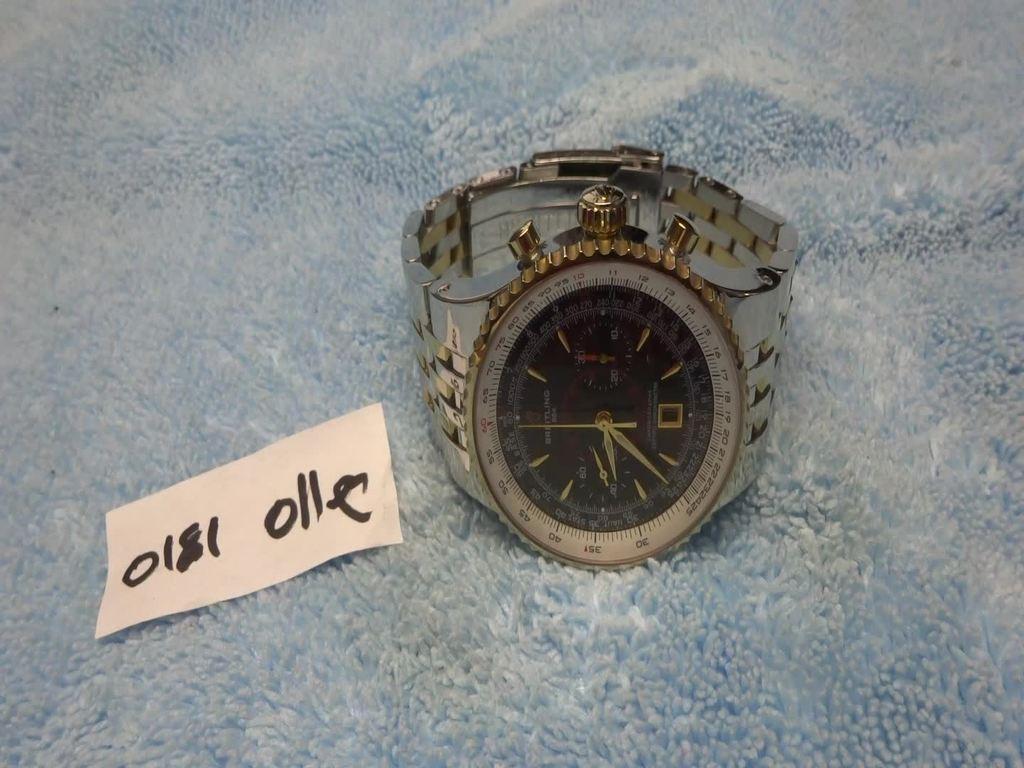Describe this image in one or two sentences. In the center of the image there is a watch and also a price tag on the cloth. 